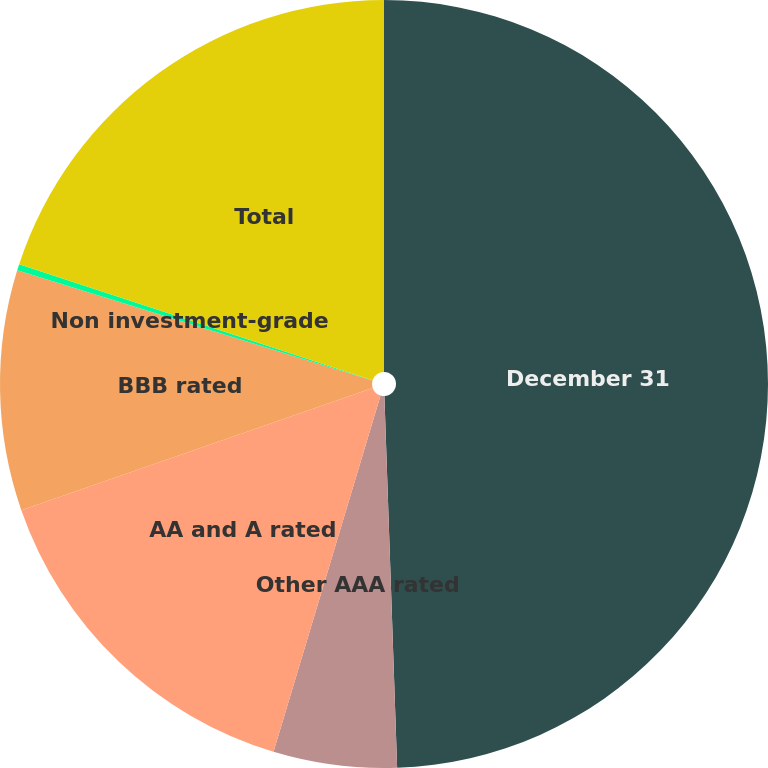Convert chart. <chart><loc_0><loc_0><loc_500><loc_500><pie_chart><fcel>December 31<fcel>Other AAA rated<fcel>AA and A rated<fcel>BBB rated<fcel>Non investment-grade<fcel>Total<nl><fcel>49.46%<fcel>5.19%<fcel>15.03%<fcel>10.11%<fcel>0.27%<fcel>19.95%<nl></chart> 